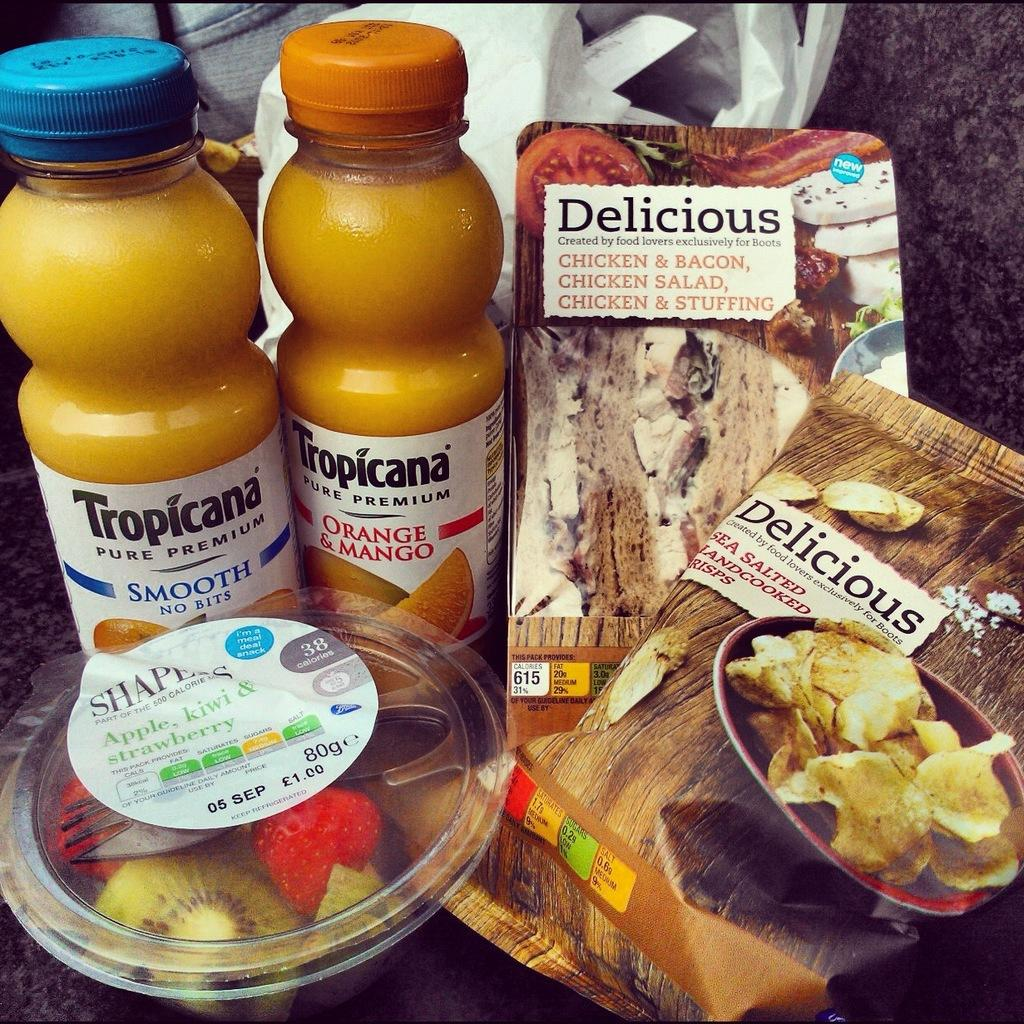What type of beverages are visible in the image? There are preservative juice drinks in the image. What other food items can be seen in the image? There are food packets and a bowl of fruits in the image. What color is the carry bag in the image? The carry bag is white in color. What type of agreement is being discussed in the image? There is no discussion or agreement present in the image; it features food items and a carry bag. 